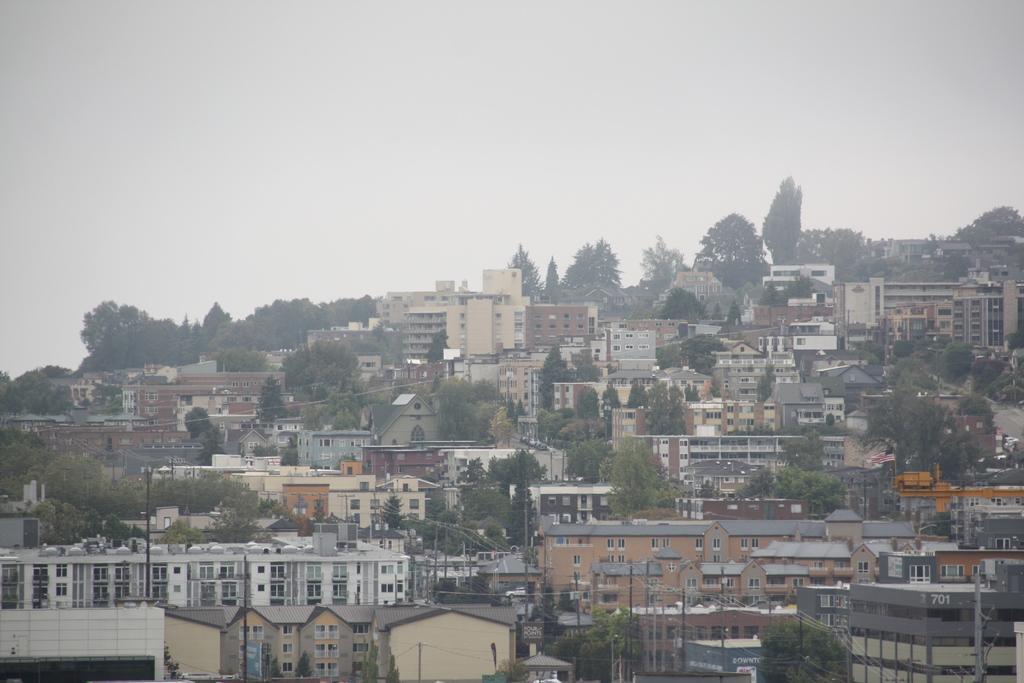Describe this image in one or two sentences. In this image we can see many buildings, trees, poles, wires and the sky in the background. 